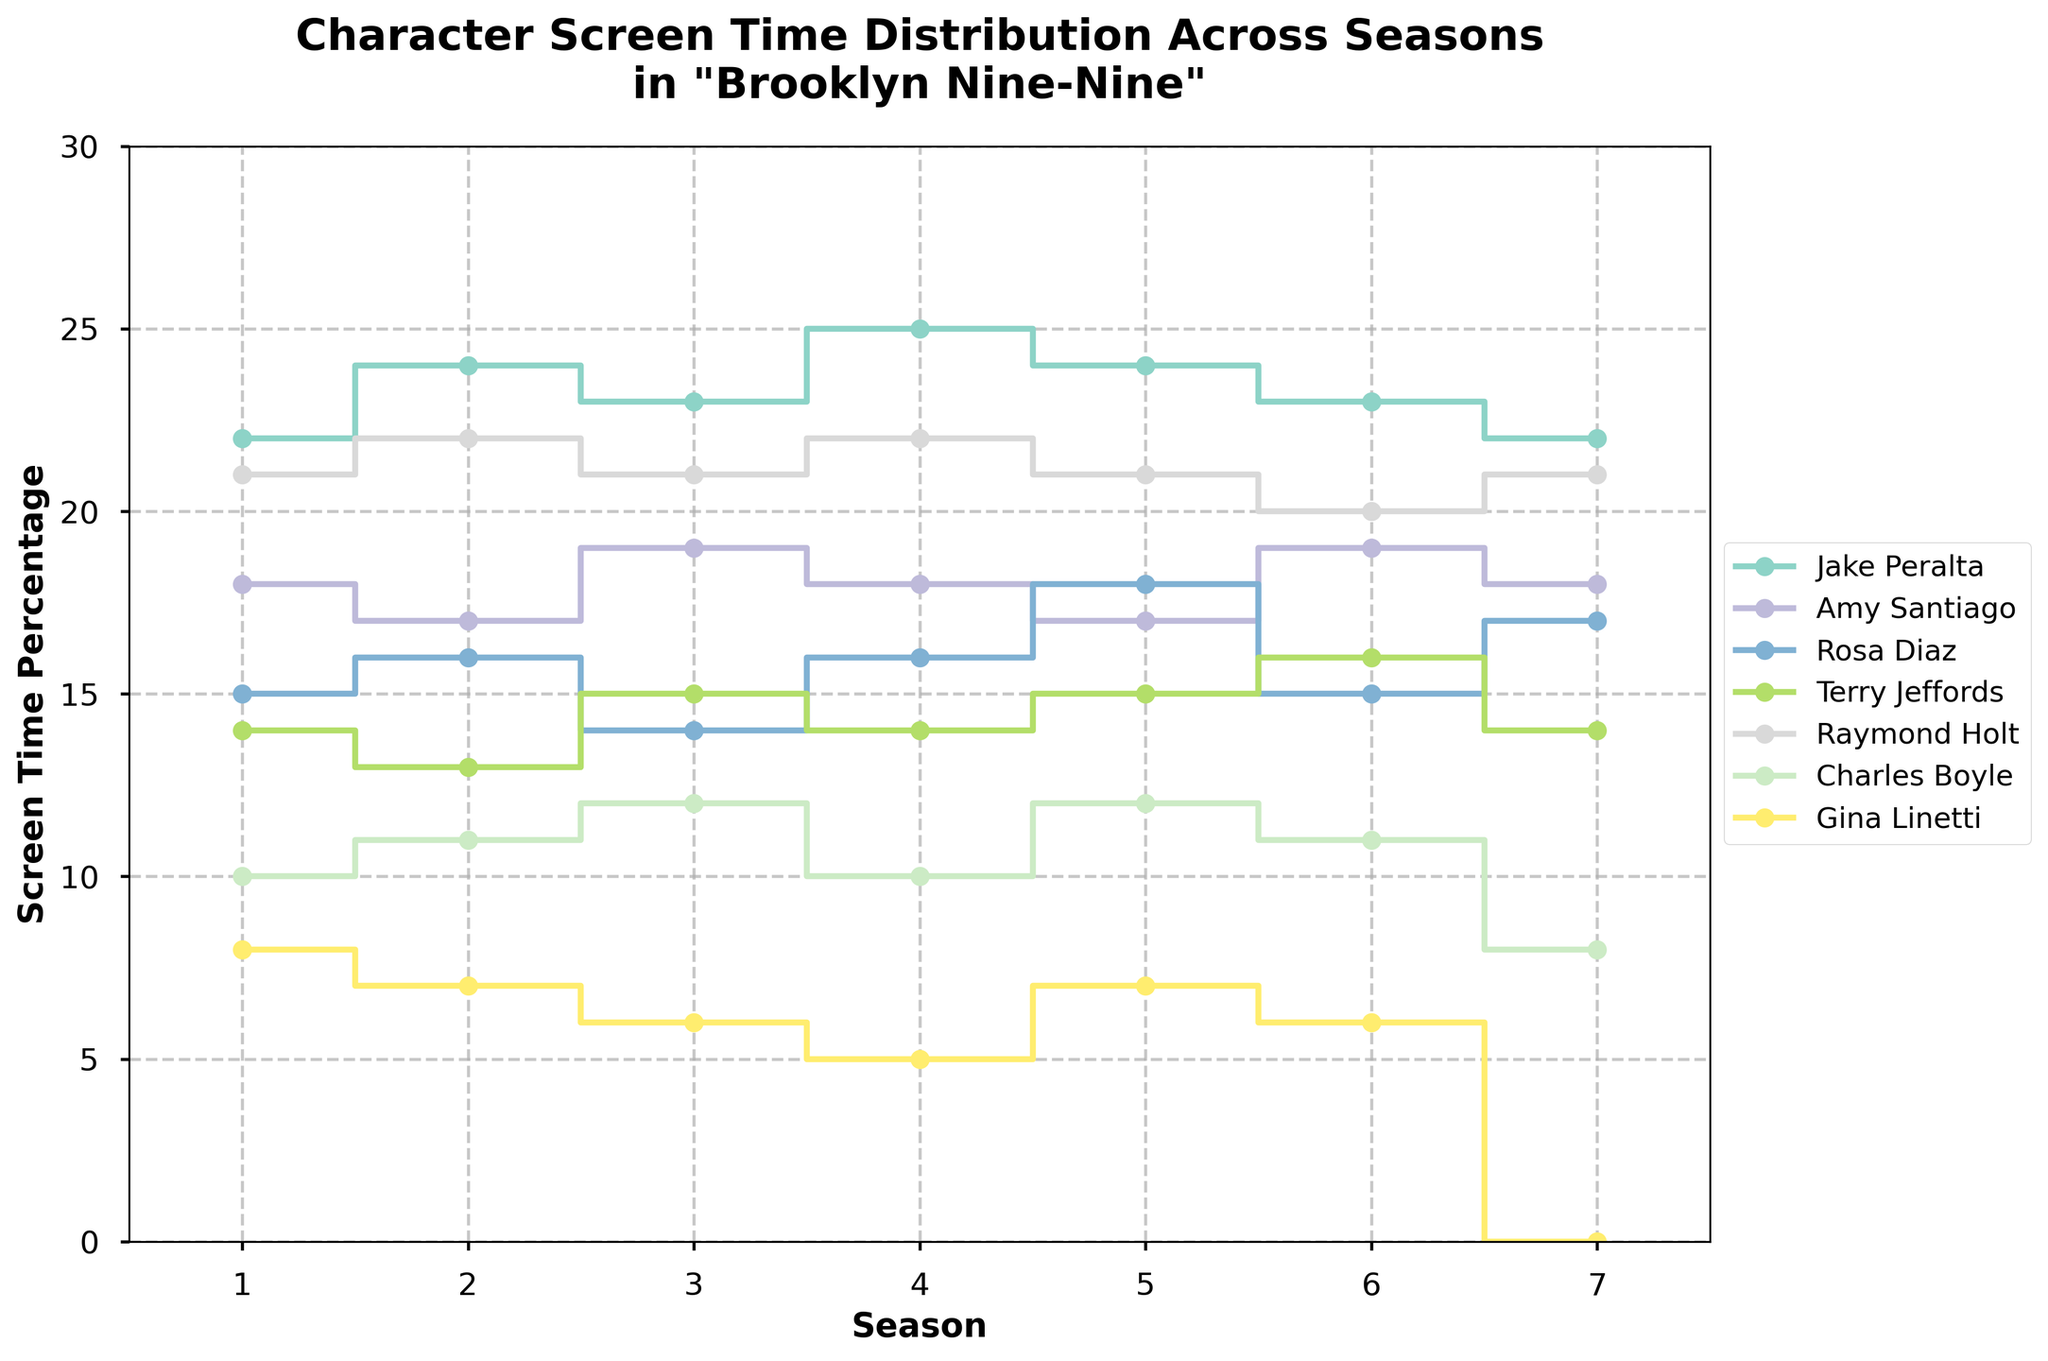What is the title of the plot? The title is usually located at the top of the plot. In this case, it reads "Character Screen Time Distribution Across Seasons in 'Brooklyn Nine-Nine'"
Answer: Character Screen Time Distribution Across Seasons in "Brooklyn Nine-Nine" Which character has the highest screen time percentage in Season 4? By tracing along the x-axis to Season 4 and then observing all the characters, Jake Peralta has the highest screen time percentage at 25%.
Answer: Jake Peralta How does Gina Linetti's screen time percentage change from Season 6 to Season 7? From Season 6 to Season 7, Gina Linetti's screen time drops from 6% to 0%. This is a decrease of 6 percentage points.
Answer: It drops from 6% to 0% What is the screen time percentage for Charles Boyle in Season 3? Locate the Season 3 column and trace Charles Boyle's line to find the value along the y-axis. It sits at 12%.
Answer: 12% Which two characters had an equal percentage of screen time in Season 1? By examining the Season 1 column and comparing the y-values, Terry Jeffords and Rosa Diaz both had 14% screen time.
Answer: Terry Jeffords and Rosa Diaz Calculate the average screen time percentage for Rosa Diaz across all seasons. Rosa Diaz's screen time percentages are: 15, 16, 14, 16, 18, 15, and 17. Summing these values gives 111. Dividing by 7 (the number of seasons) results in an average of 15.86%.
Answer: 15.86% Who has the most consistent screen time percentage across all seasons? To determine consistency, observe the lines for each character. Raymond Holt's line appears relatively flat, ranging only between 20% and 22% across seasons.
Answer: Raymond Holt Between Jake Peralta and Amy Santiago, who experienced a higher change in screen time percentage from Season 5 to Season 6? Jake Peralta's screen time changes from 24% to 23% (a decrease of 1%). Amy Santiago's screen time changes from 17% to 19% (an increase of 2%). Amy Santiago experienced a higher change.
Answer: Amy Santiago What is the sum of the screen time percentages for Raymond Holt in Seasons 2, 3, and 4? Raymond Holt's screen time percentages for Seasons 2, 3, and 4 are 22, 21, and 22. The sum is 22 + 21 + 22 = 65.
Answer: 65 